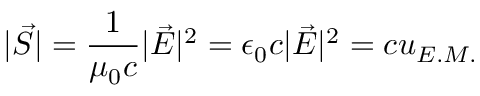<formula> <loc_0><loc_0><loc_500><loc_500>| \vec { S } | = \frac { 1 } { \mu _ { 0 } c } | \vec { E } | ^ { 2 } = \epsilon _ { 0 } c | \vec { E } | ^ { 2 } = c u _ { E . M . }</formula> 